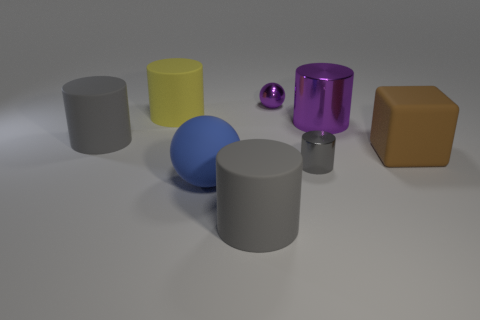Is the shape of the yellow rubber thing the same as the gray thing that is to the left of the big blue matte thing?
Ensure brevity in your answer.  Yes. How many other purple cylinders are the same size as the purple cylinder?
Provide a short and direct response. 0. What number of big gray rubber things are behind the gray matte cylinder in front of the shiny cylinder that is in front of the big rubber cube?
Provide a succinct answer. 1. Are there an equal number of blue rubber balls to the left of the large blue matte thing and tiny shiny balls that are on the right side of the purple cylinder?
Your answer should be compact. Yes. What number of tiny purple things are the same shape as the big purple thing?
Your answer should be very brief. 0. Are there any large gray things that have the same material as the big brown cube?
Give a very brief answer. Yes. There is a tiny metal thing that is the same color as the large shiny object; what shape is it?
Your answer should be compact. Sphere. How many green metallic cylinders are there?
Ensure brevity in your answer.  0. What number of blocks are large gray objects or gray objects?
Make the answer very short. 0. There is a cylinder that is the same size as the purple ball; what color is it?
Give a very brief answer. Gray. 